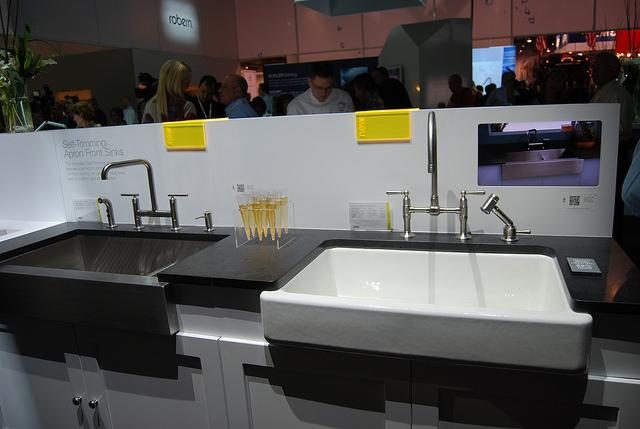What is found in the room? Please explain your reasoning. sink. There are two of them with faucets 